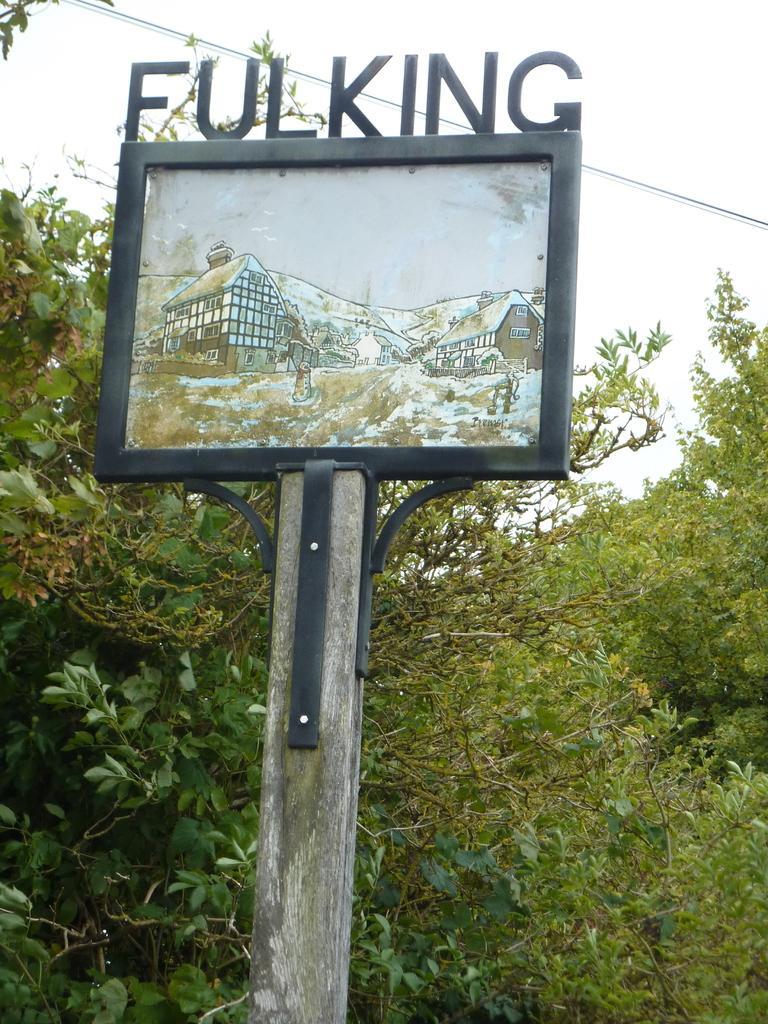Describe this image in one or two sentences. Here in this picture we can see a board present on a pole over there and on the top of it we can see a name present over there and behind that we can see plants and trees present all over there. 